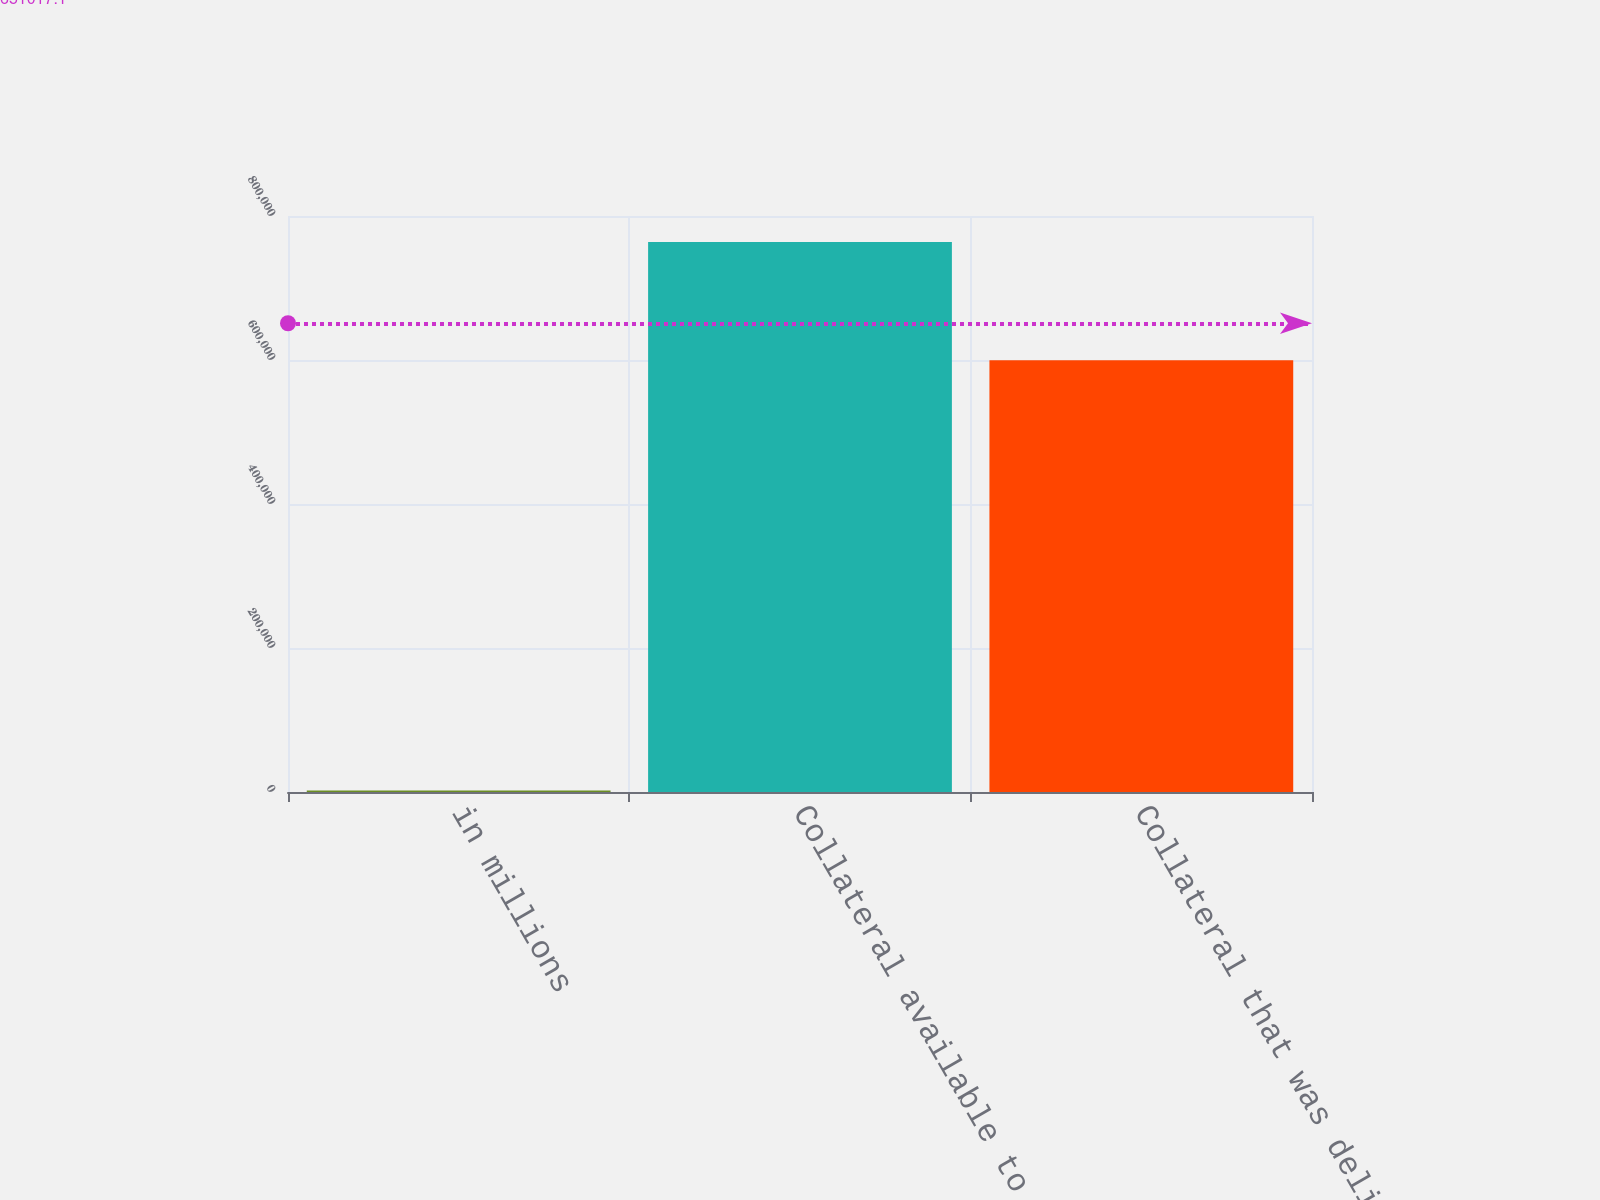Convert chart to OTSL. <chart><loc_0><loc_0><loc_500><loc_500><bar_chart><fcel>in millions<fcel>Collateral available to be<fcel>Collateral that was delivered<nl><fcel>2017<fcel>763984<fcel>599565<nl></chart> 